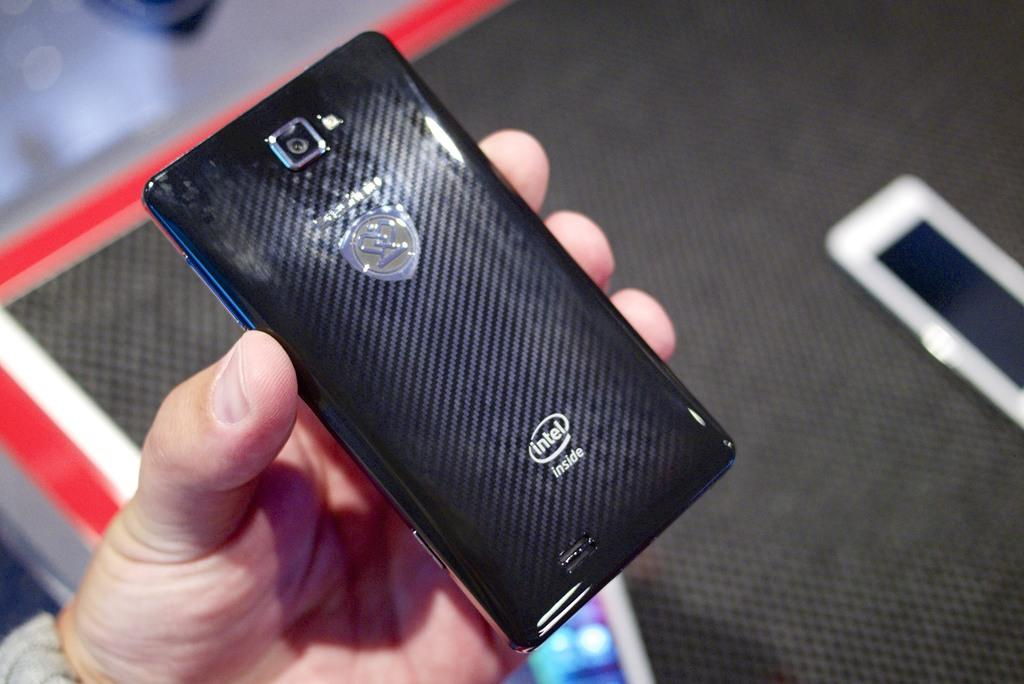<image>
Summarize the visual content of the image. A hand is holding a phone displaying that it comes with intel. 